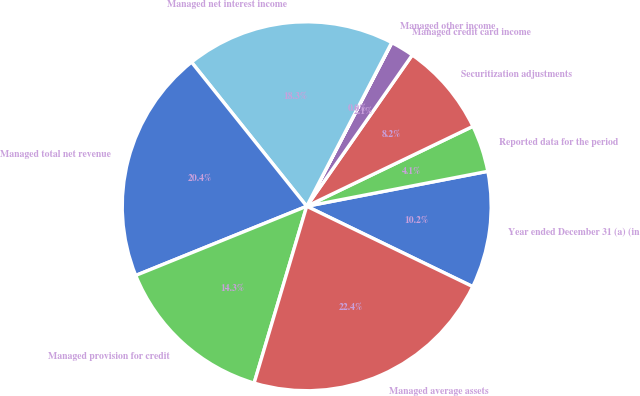Convert chart. <chart><loc_0><loc_0><loc_500><loc_500><pie_chart><fcel>Year ended December 31 (a) (in<fcel>Reported data for the period<fcel>Securitization adjustments<fcel>Managed credit card income<fcel>Managed other income<fcel>Managed net interest income<fcel>Managed total net revenue<fcel>Managed provision for credit<fcel>Managed average assets<nl><fcel>10.21%<fcel>4.1%<fcel>8.17%<fcel>2.06%<fcel>0.02%<fcel>18.35%<fcel>20.39%<fcel>14.28%<fcel>22.43%<nl></chart> 